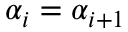Convert formula to latex. <formula><loc_0><loc_0><loc_500><loc_500>\alpha _ { i } = \alpha _ { i + 1 }</formula> 